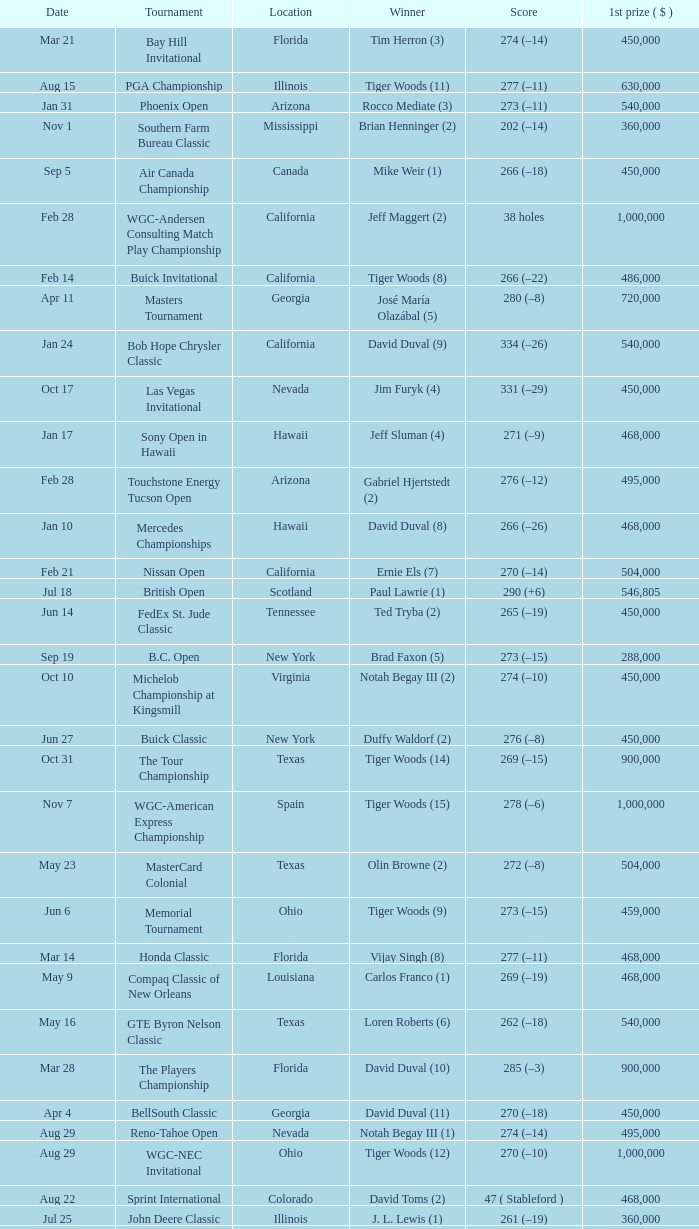What is the score of the B.C. Open in New York? 273 (–15). Could you parse the entire table? {'header': ['Date', 'Tournament', 'Location', 'Winner', 'Score', '1st prize ( $ )'], 'rows': [['Mar 21', 'Bay Hill Invitational', 'Florida', 'Tim Herron (3)', '274 (–14)', '450,000'], ['Aug 15', 'PGA Championship', 'Illinois', 'Tiger Woods (11)', '277 (–11)', '630,000'], ['Jan 31', 'Phoenix Open', 'Arizona', 'Rocco Mediate (3)', '273 (–11)', '540,000'], ['Nov 1', 'Southern Farm Bureau Classic', 'Mississippi', 'Brian Henninger (2)', '202 (–14)', '360,000'], ['Sep 5', 'Air Canada Championship', 'Canada', 'Mike Weir (1)', '266 (–18)', '450,000'], ['Feb 28', 'WGC-Andersen Consulting Match Play Championship', 'California', 'Jeff Maggert (2)', '38 holes', '1,000,000'], ['Feb 14', 'Buick Invitational', 'California', 'Tiger Woods (8)', '266 (–22)', '486,000'], ['Apr 11', 'Masters Tournament', 'Georgia', 'José María Olazábal (5)', '280 (–8)', '720,000'], ['Jan 24', 'Bob Hope Chrysler Classic', 'California', 'David Duval (9)', '334 (–26)', '540,000'], ['Oct 17', 'Las Vegas Invitational', 'Nevada', 'Jim Furyk (4)', '331 (–29)', '450,000'], ['Jan 17', 'Sony Open in Hawaii', 'Hawaii', 'Jeff Sluman (4)', '271 (–9)', '468,000'], ['Feb 28', 'Touchstone Energy Tucson Open', 'Arizona', 'Gabriel Hjertstedt (2)', '276 (–12)', '495,000'], ['Jan 10', 'Mercedes Championships', 'Hawaii', 'David Duval (8)', '266 (–26)', '468,000'], ['Feb 21', 'Nissan Open', 'California', 'Ernie Els (7)', '270 (–14)', '504,000'], ['Jul 18', 'British Open', 'Scotland', 'Paul Lawrie (1)', '290 (+6)', '546,805'], ['Jun 14', 'FedEx St. Jude Classic', 'Tennessee', 'Ted Tryba (2)', '265 (–19)', '450,000'], ['Sep 19', 'B.C. Open', 'New York', 'Brad Faxon (5)', '273 (–15)', '288,000'], ['Oct 10', 'Michelob Championship at Kingsmill', 'Virginia', 'Notah Begay III (2)', '274 (–10)', '450,000'], ['Jun 27', 'Buick Classic', 'New York', 'Duffy Waldorf (2)', '276 (–8)', '450,000'], ['Oct 31', 'The Tour Championship', 'Texas', 'Tiger Woods (14)', '269 (–15)', '900,000'], ['Nov 7', 'WGC-American Express Championship', 'Spain', 'Tiger Woods (15)', '278 (–6)', '1,000,000'], ['May 23', 'MasterCard Colonial', 'Texas', 'Olin Browne (2)', '272 (–8)', '504,000'], ['Jun 6', 'Memorial Tournament', 'Ohio', 'Tiger Woods (9)', '273 (–15)', '459,000'], ['Mar 14', 'Honda Classic', 'Florida', 'Vijay Singh (8)', '277 (–11)', '468,000'], ['May 9', 'Compaq Classic of New Orleans', 'Louisiana', 'Carlos Franco (1)', '269 (–19)', '468,000'], ['May 16', 'GTE Byron Nelson Classic', 'Texas', 'Loren Roberts (6)', '262 (–18)', '540,000'], ['Mar 28', 'The Players Championship', 'Florida', 'David Duval (10)', '285 (–3)', '900,000'], ['Apr 4', 'BellSouth Classic', 'Georgia', 'David Duval (11)', '270 (–18)', '450,000'], ['Aug 29', 'Reno-Tahoe Open', 'Nevada', 'Notah Begay III (1)', '274 (–14)', '495,000'], ['Aug 29', 'WGC-NEC Invitational', 'Ohio', 'Tiger Woods (12)', '270 (–10)', '1,000,000'], ['Aug 22', 'Sprint International', 'Colorado', 'David Toms (2)', '47 ( Stableford )', '468,000'], ['Jul 25', 'John Deere Classic', 'Illinois', 'J. L. Lewis (1)', '261 (–19)', '360,000'], ['Apr 25', 'Greater Greensboro Chrysler Classic', 'North Carolina', 'Jesper Parnevik (2)', '265 (–23)', '468,000'], ['Jul 4', 'Motorola Western Open', 'Illinois', 'Tiger Woods (10)', '273 (–15)', '450,000'], ['Jul 11', 'Greater Milwaukee Open', 'Wisconsin', 'Carlos Franco (2)', '264 (–20)', '414,000'], ['Apr 18', 'MCI Classic', 'South Carolina', 'Glen Day (1)', '274 (–10)', '450,000'], ['Oct 3', 'Buick Challenge', 'Georgia', 'David Toms (3)', '271 (–17)', '324,000'], ['Mar 7', 'Doral-Ryder Open', 'Florida', 'Steve Elkington (10)', '275 (–13)', '540,000'], ['Aug 8', 'Buick Open', 'Michigan', 'Tom Pernice, Jr. (1)', '270 (–18)', '432,000'], ['Oct 24', 'National Car Rental Golf Classic Disney', 'Florida', 'Tiger Woods (13)', '271 (–17)', '450,000'], ['Sep 12', 'Bell Canadian Open', 'Canada', 'Hal Sutton (11)', '275 (–13)', '450,000'], ['Aug 1', 'Canon Greater Hartford Open', 'Connecticut', 'Brent Geiberger (1)', '262 (–18)', '450,000'], ['Feb 7', 'AT&T Pebble Beach National Pro-Am', 'California', 'Payne Stewart (10)', '206 (–10)', '504,000'], ['May 2', 'Shell Houston Open', 'Texas', 'Stuart Appleby (3)', '279 (–9)', '450,000'], ['May 30', 'Kemper Open', 'Maryland', 'Rich Beem (1)', '274 (–10)', '450,000'], ['Jun 20', 'U.S. Open', 'North Carolina', 'Payne Stewart (11)', '279 (–1)', '625,000'], ['Sep 26', 'Westin Texas Open', 'Texas', 'Duffy Waldorf (3)', '270 (–18)', '360,000']]} 